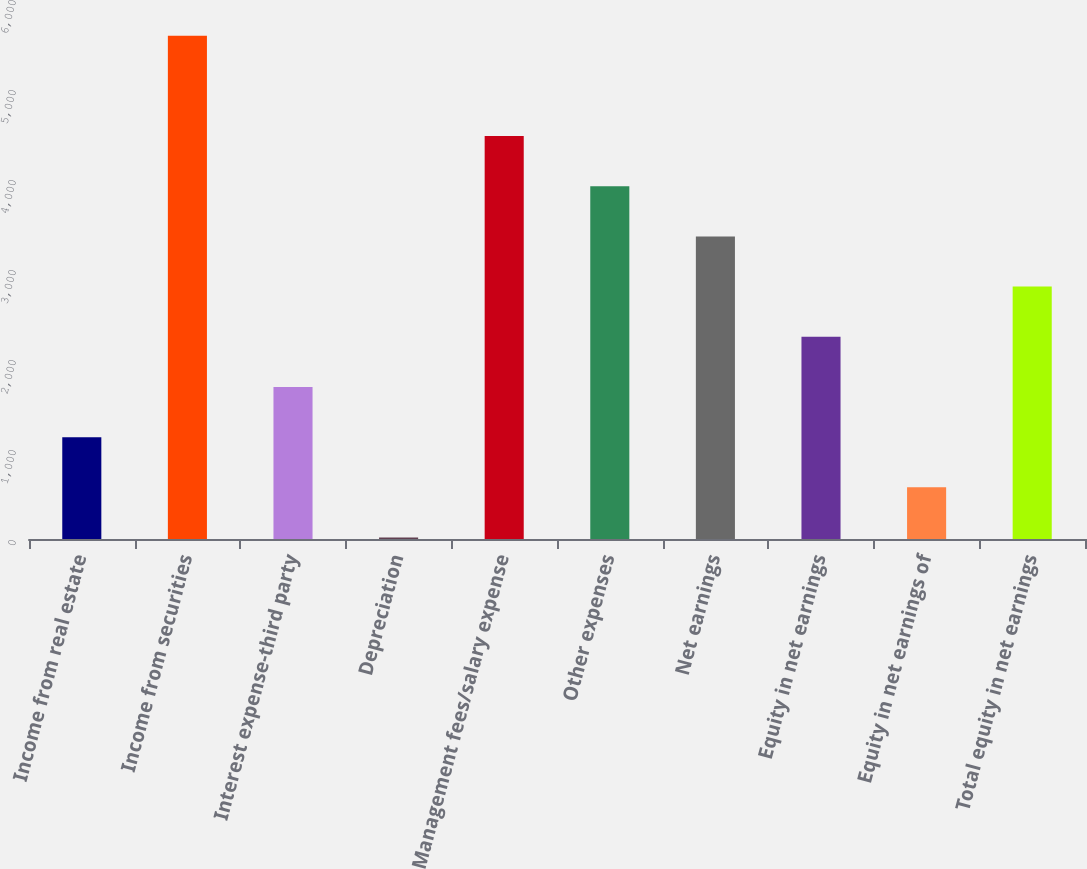Convert chart. <chart><loc_0><loc_0><loc_500><loc_500><bar_chart><fcel>Income from real estate<fcel>Income from securities<fcel>Interest expense-third party<fcel>Depreciation<fcel>Management fees/salary expense<fcel>Other expenses<fcel>Net earnings<fcel>Equity in net earnings<fcel>Equity in net earnings of<fcel>Total equity in net earnings<nl><fcel>1131.4<fcel>5593<fcel>1689.1<fcel>16<fcel>4477.6<fcel>3919.9<fcel>3362.2<fcel>2246.8<fcel>573.7<fcel>2804.5<nl></chart> 